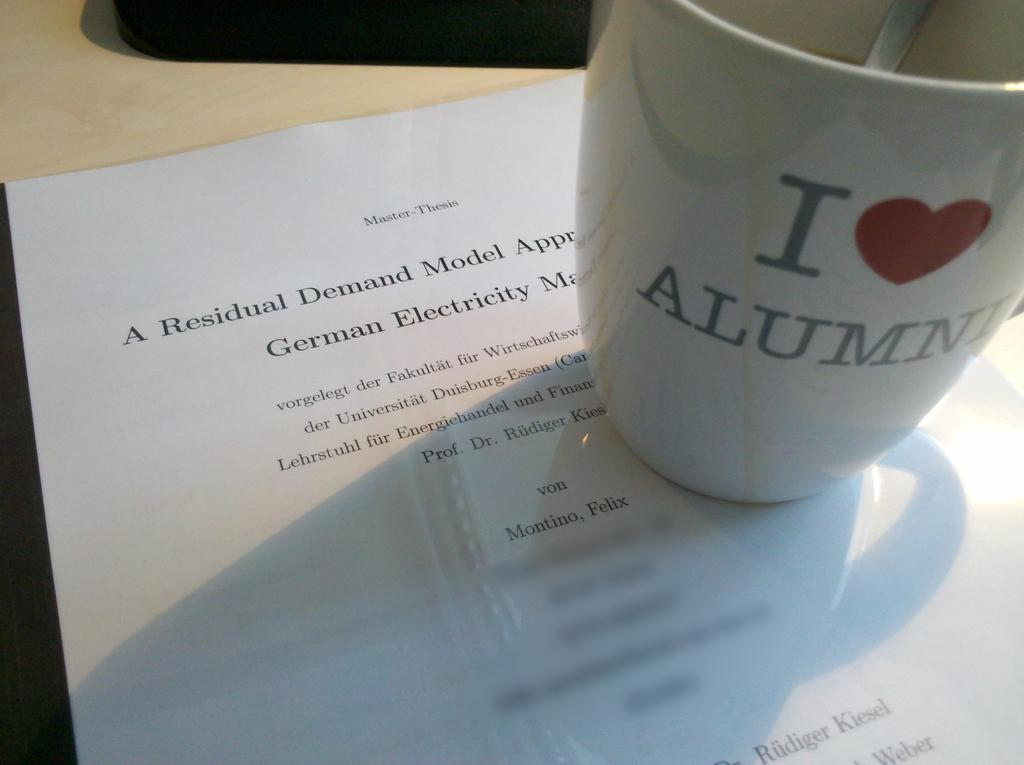What type of object is present at the top of the image? There is a mug in the image. What utensil can be seen in the image? There is a spoon in the image. What is located at the bottom of the image? There is a paper at the bottom of the image. What type of glove is being used to play chess in the image? There is no glove or chess game present in the image. 